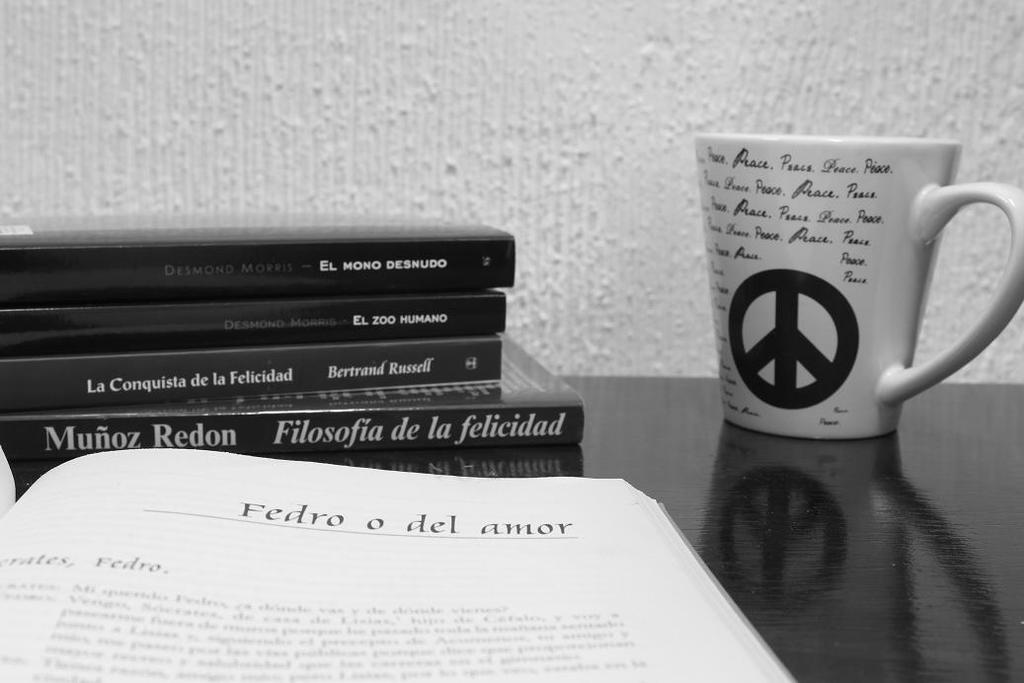<image>
Relay a brief, clear account of the picture shown. A mug that says peace multiple times with an open book that says  Fedro o del amor at the top of the page. 